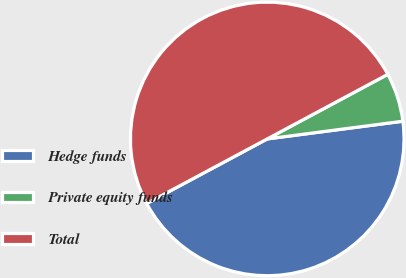Convert chart. <chart><loc_0><loc_0><loc_500><loc_500><pie_chart><fcel>Hedge funds<fcel>Private equity funds<fcel>Total<nl><fcel>44.24%<fcel>5.76%<fcel>50.0%<nl></chart> 